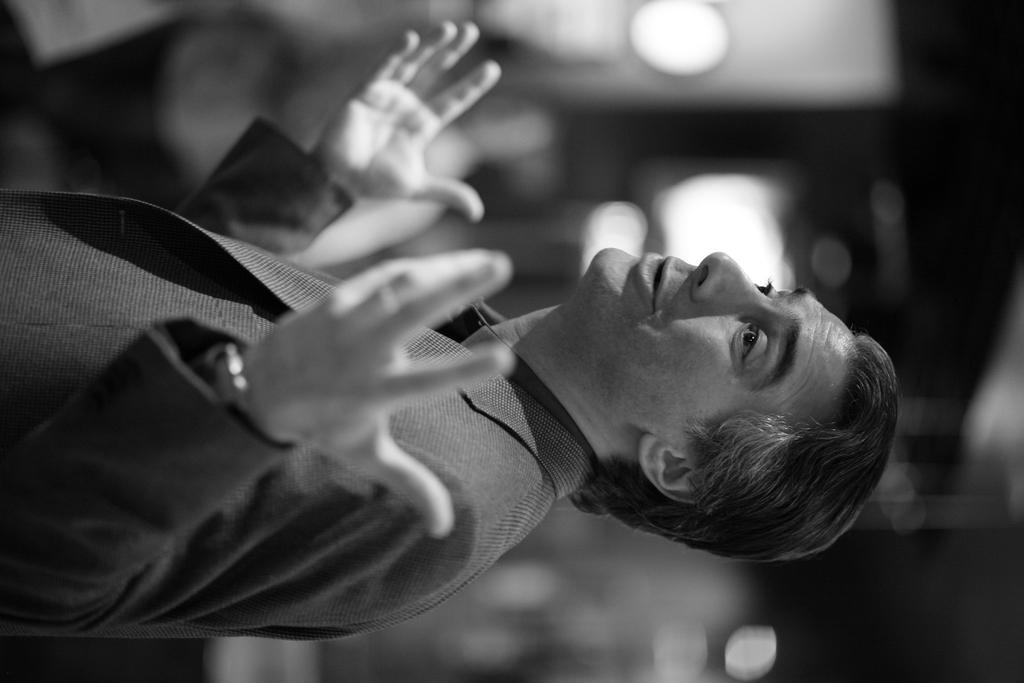Can you describe this image briefly? In the middle of the image a person is standing. Background of the image is blur. 